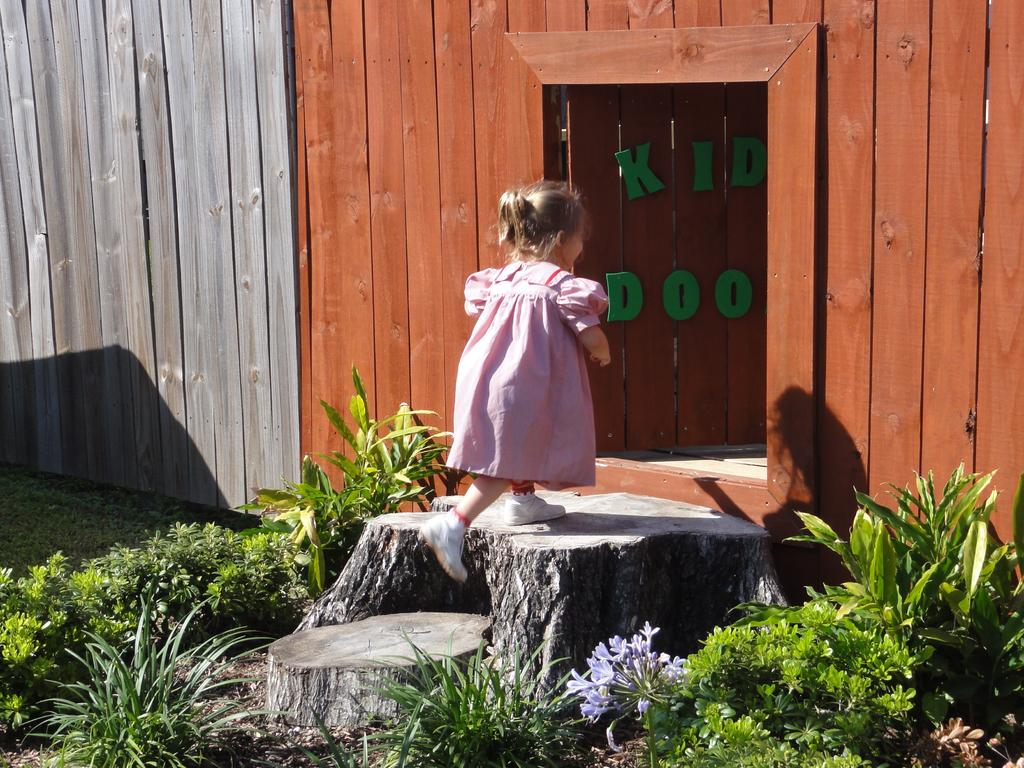What is the main subject of the image? There is a girl walking in the image. What type of natural elements can be seen in the image? Plants are visible in the image. What material is covering the ground in the image? There are wooden barks on the ground in the image. What is written or displayed on a wooden wall in the image? There is text on a wooden wall in the image. What type of acoustics can be heard in the image? There is no information about any sounds or acoustics in the image, so it cannot be determined. --- Facts: 1. There is a car in the image. 2. The car is red. 3. The car has four wheels. 4. There are people standing near the car. 5. The people are holding bags. Absurd Topics: parrot, sand, ocean Conversation: What is the main subject of the image? The main subject of the image is a car. What color is the car in the image? The car is red. How many wheels does the car have? The car has four wheels. What are the people near the car doing? The people standing near the car are holding bags. Reasoning: Let's think step by step in order to produce the conversation. We start by identifying the main subject of the image, which is the car. Then, we describe the color and number of wheels of the car. Next, we observe the actions of the people in the image, noting that they are holding bags, which suggests they may have just returned from shopping or a trip. Each question is designed to elicit a specific detail about the image that is known from the provided facts. Absurd Question/Answer: Can you see a parrot sitting on the car in the image? No, there is no parrot present in the image. What type of sand can be seen near the car in the image? There is no sand visible in the image; it appears to be a paved or concrete surface. --- Facts: 1. There is a group of people sitting on a bench in the image. 2. The bench is made of wood. 3. There is a tree behind the bench. 4. The sky is visible in the image. Absurd Topics: elephant, snow, mountain Conversation: What is the main subject of the image? The main subject of the image is a group of people sitting on a bench. What material is the bench made of? The bench is made of wood. What is located behind the bench in the image? There is a tree behind the bench. What is visible in the background of the image? The sky is visible in the image. Reasoning: Let's think step by step in order to produce the conversation. We start by 